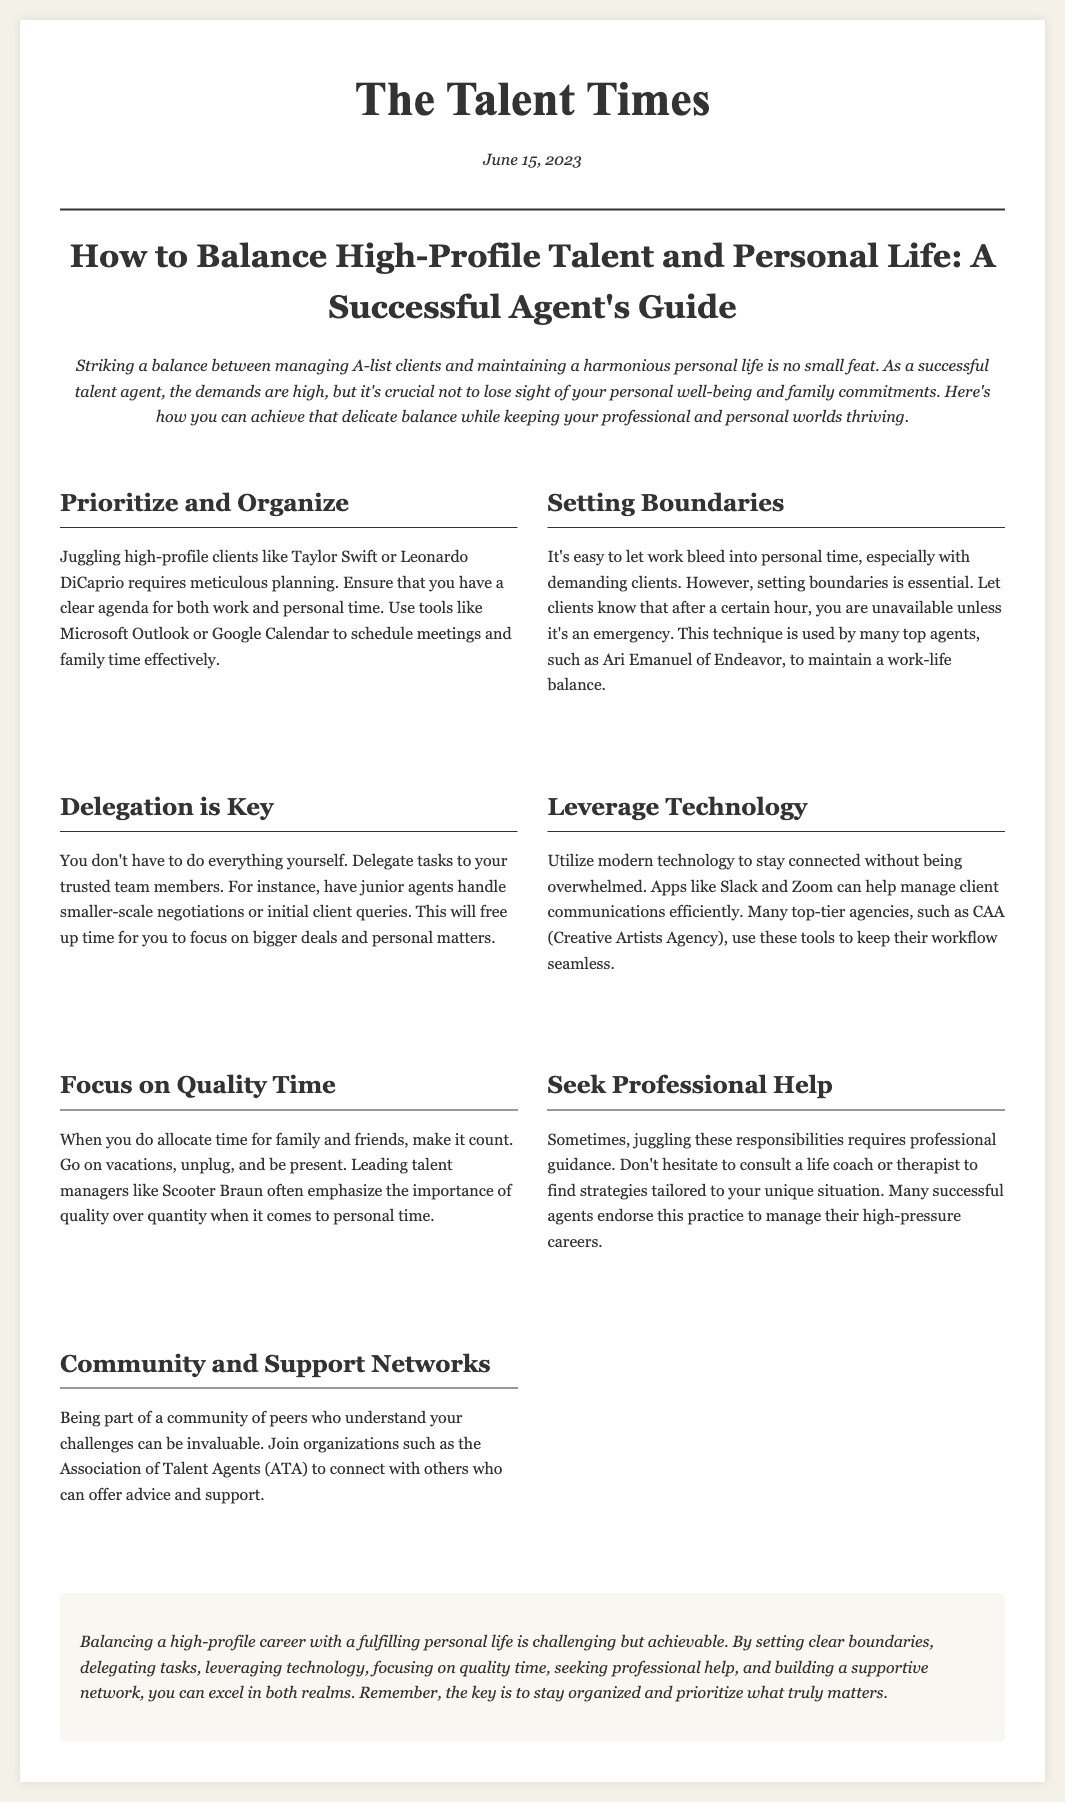What is the date of publication? The publication date is clearly stated at the top of the document under the date section.
Answer: June 15, 2023 Who is an example of a high-profile client mentioned? The document provides specific examples of clients in its content, especially within the section discussing planning.
Answer: Taylor Swift What is the main focus of the article? The primary theme of the article is summarized in the title and the intro, reflecting its intention.
Answer: Balance What tool is suggested for scheduling meetings? The document contains specific tools mentioned in the context of planning and organization.
Answer: Google Calendar What should agents do to maintain personal time? This concept is discussed in several sections, outlining strategies to keep work and personal life separate.
Answer: Set boundaries How many sections does the content have? A count of the sections can be made by identifying each defined section within the content area.
Answer: Seven What is a key practice endorsed for managing careers? The document describes several recommended strategies for successful management, including consulting professionals.
Answer: Seek Professional Help What networking organization is mentioned? Specific organizations are referred to within the context of building support and networking for agents.
Answer: Association of Talent Agents What is emphasized when spending time with family? The content speaks to the importance of the quality of interactions rather than the amount of time spent.
Answer: Quality over quantity 